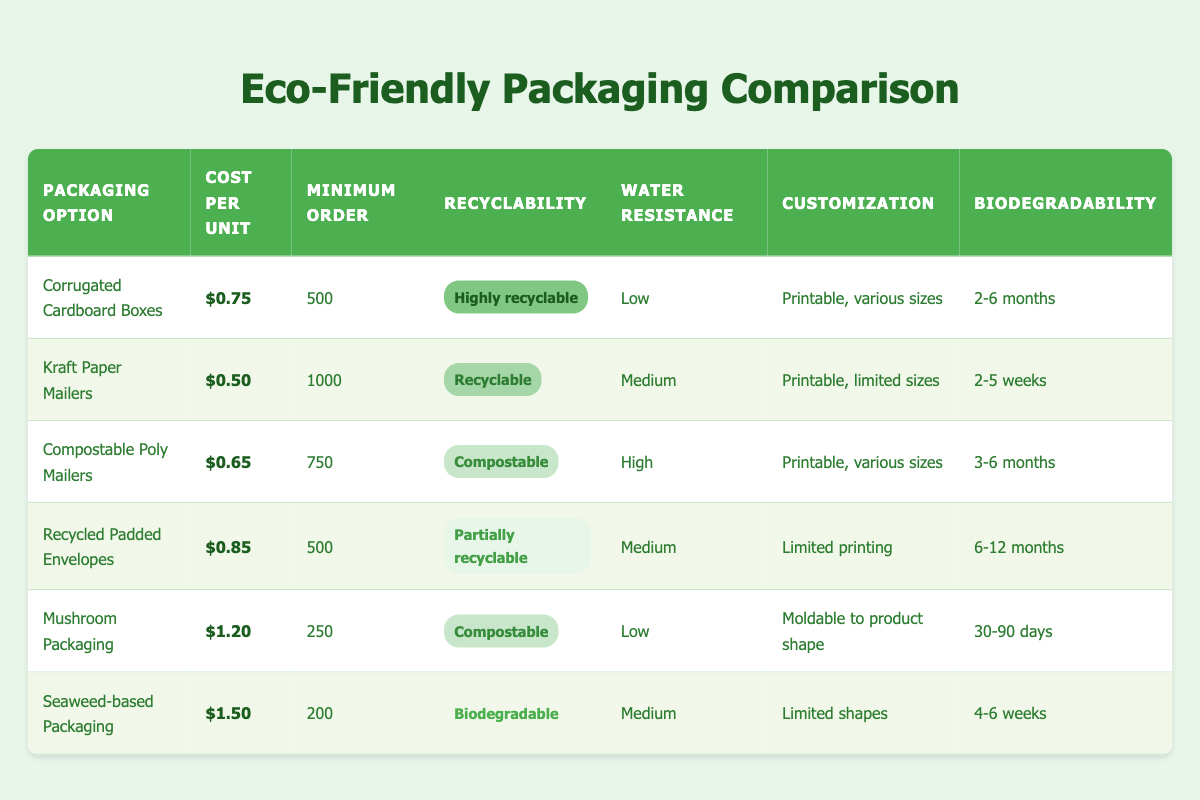What is the cost per unit for Kraft Paper Mailers? The table lists Kraft Paper Mailers under the "Packaging Option" column, and the corresponding "Cost per Unit" is in the row next to it, which is $0.50.
Answer: $0.50 Which packaging option has the lowest minimum order quantity? Looking at the "Minimum Order" column, the quantities for all packaging options are compared. The Mushroom Packaging option has the lowest minimum order quantity at 250.
Answer: 250 How many days does it take for Mushroom Packaging to biodegrade? The "Biodegradability" column shows the biodegradation time for Mushroom Packaging is 30-90 days.
Answer: 30-90 days What is the average cost per unit of all the packaging options listed? To find the average cost per unit, sum the costs; $0.75 + $0.50 + $0.65 + $0.85 + $1.20 + $1.50 = $5.45. There are 6 packaging options, so average = $5.45 / 6 = $0.9083, rounded to $0.91.
Answer: $0.91 Is Seaweed-based Packaging recyclable? The "Recyclability" column indicates that Seaweed-based Packaging is labeled as biodegradable, which is not the same as recyclable. Therefore, the answer is no.
Answer: No Which packaging option has the best water resistance and what is that level? The "Water Resistance" column shows that Compostable Poly Mailers have a water resistance level of High, which is the best among the options.
Answer: High How many packaging options are compostable? By checking the "Recyclability" column, Compostable Poly Mailers and Mushroom Packaging are the only options marked as compostable. There are 2 options.
Answer: 2 What is the total cost for ordering the minimum quantity of Kraft Paper Mailers? The cost per unit is $0.50, and the minimum order quantity is 1000. Therefore, total cost is 1000 * $0.50 = $500.
Answer: $500 Which option has both medium water resistance and is recyclable? Upon analyzing the table, Kraft Paper Mailers and Recycled Padded Envelopes both have medium water resistance. However, only Kraft Paper Mailers are recyclable based on the "Recyclability" column.
Answer: Kraft Paper Mailers 